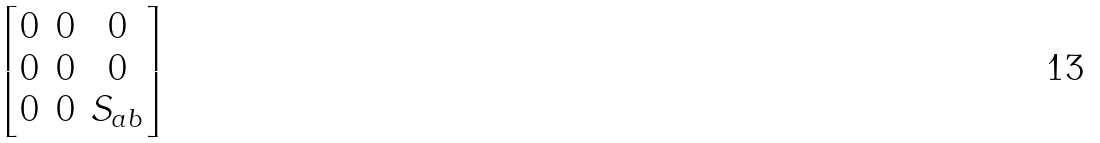<formula> <loc_0><loc_0><loc_500><loc_500>\begin{bmatrix} 0 & 0 & 0 \\ 0 & 0 & 0 \\ 0 & 0 & S _ { a b } \end{bmatrix}</formula> 